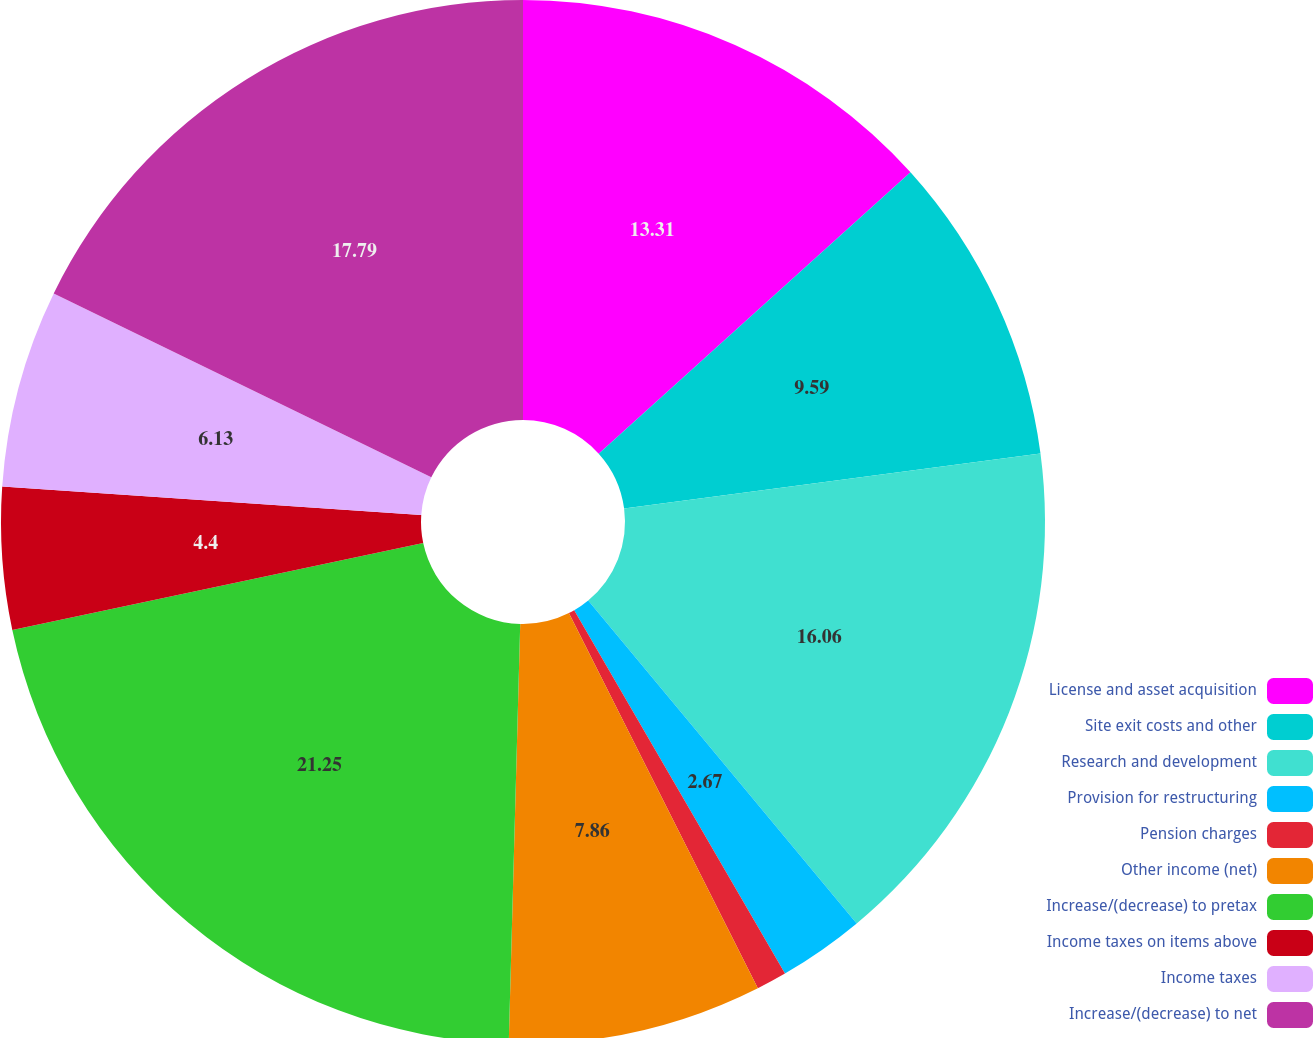Convert chart to OTSL. <chart><loc_0><loc_0><loc_500><loc_500><pie_chart><fcel>License and asset acquisition<fcel>Site exit costs and other<fcel>Research and development<fcel>Provision for restructuring<fcel>Pension charges<fcel>Other income (net)<fcel>Increase/(decrease) to pretax<fcel>Income taxes on items above<fcel>Income taxes<fcel>Increase/(decrease) to net<nl><fcel>13.31%<fcel>9.59%<fcel>16.05%<fcel>2.67%<fcel>0.94%<fcel>7.86%<fcel>21.24%<fcel>4.4%<fcel>6.13%<fcel>17.78%<nl></chart> 